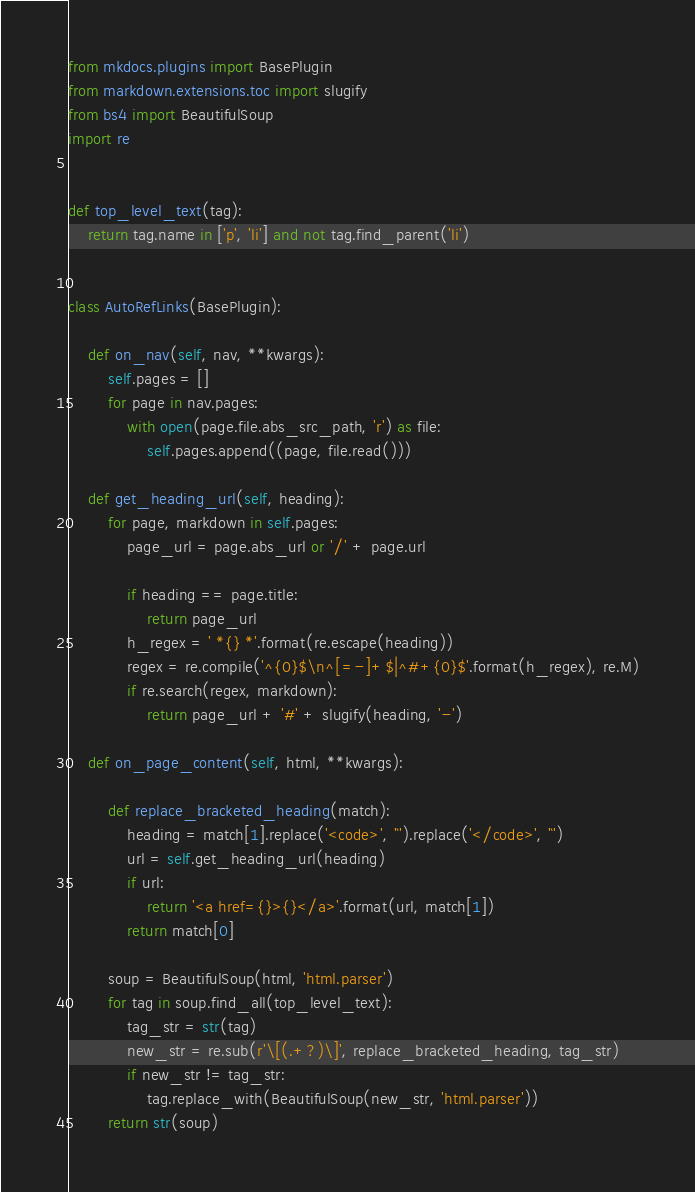<code> <loc_0><loc_0><loc_500><loc_500><_Python_>from mkdocs.plugins import BasePlugin
from markdown.extensions.toc import slugify
from bs4 import BeautifulSoup
import re


def top_level_text(tag):
    return tag.name in ['p', 'li'] and not tag.find_parent('li')


class AutoRefLinks(BasePlugin):

    def on_nav(self, nav, **kwargs):
        self.pages = []
        for page in nav.pages:
            with open(page.file.abs_src_path, 'r') as file:
                self.pages.append((page, file.read()))

    def get_heading_url(self, heading):
        for page, markdown in self.pages:
            page_url = page.abs_url or '/' + page.url

            if heading == page.title:
                return page_url
            h_regex = ' *{} *'.format(re.escape(heading))
            regex = re.compile('^{0}$\n^[=-]+$|^#+{0}$'.format(h_regex), re.M)
            if re.search(regex, markdown):
                return page_url + '#' + slugify(heading, '-')

    def on_page_content(self, html, **kwargs):

        def replace_bracketed_heading(match):
            heading = match[1].replace('<code>', '`').replace('</code>', '`')
            url = self.get_heading_url(heading)
            if url:
                return '<a href={}>{}</a>'.format(url, match[1])
            return match[0]

        soup = BeautifulSoup(html, 'html.parser')
        for tag in soup.find_all(top_level_text):
            tag_str = str(tag)
            new_str = re.sub(r'\[(.+?)\]', replace_bracketed_heading, tag_str)
            if new_str != tag_str:
                tag.replace_with(BeautifulSoup(new_str, 'html.parser'))
        return str(soup)
</code> 